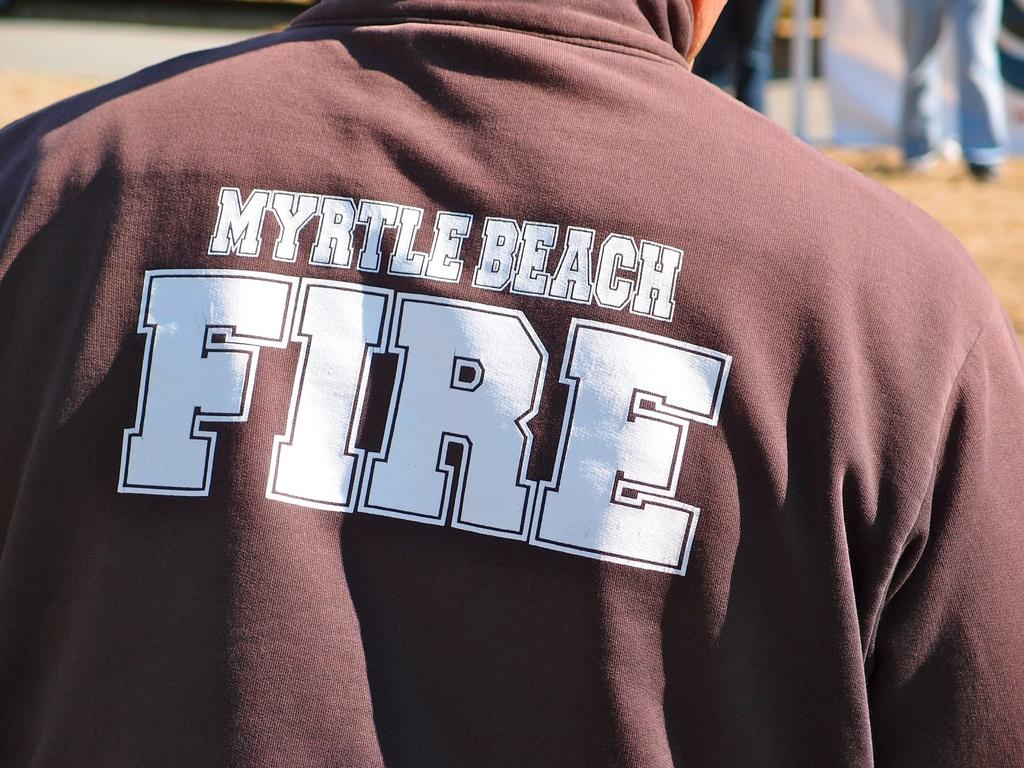<image>
Offer a succinct explanation of the picture presented. FIRE is written in big letters on the back of this person's shirt. 